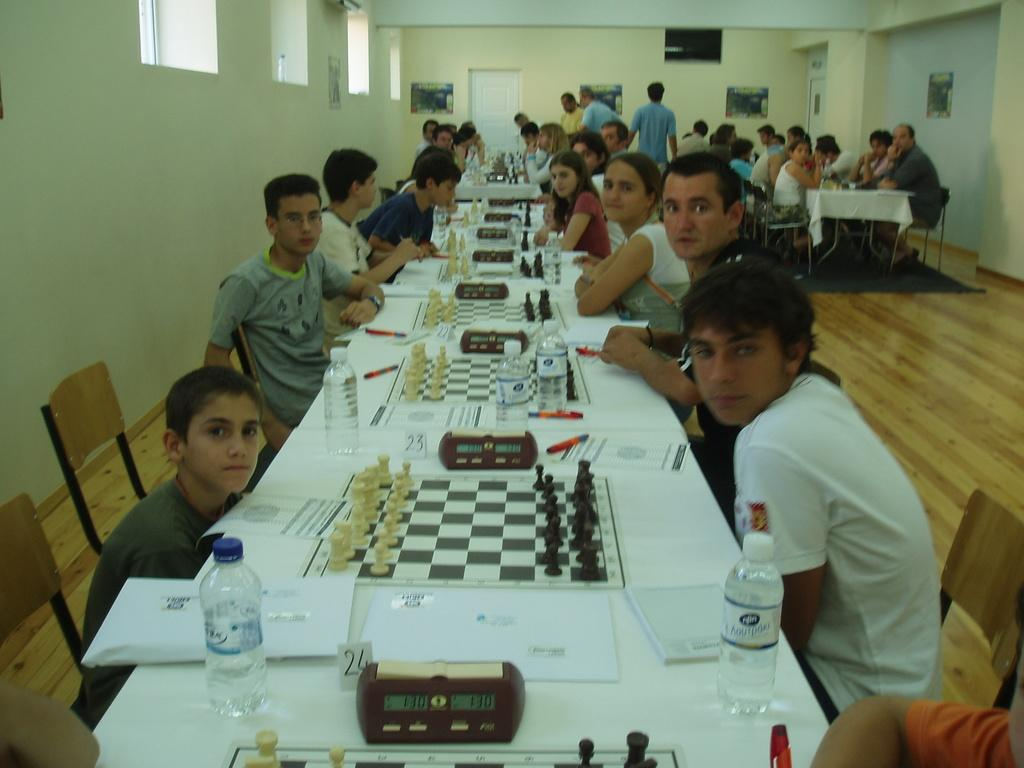How many people are in the image? There is a group of people in the image. What are the people doing in the image? The people are sitting on chairs. What is on the table in the image? There is a laptop, a bottle, a pen, and a sketch on the table. What can be seen in the background of the image? There is a wall and a door visible in the background. How many women are playing soccer in the yard in the image? There are no women playing soccer in the yard in the image. The image features a group of people sitting at a table with various objects, and there is no yard or soccer game depicted. 